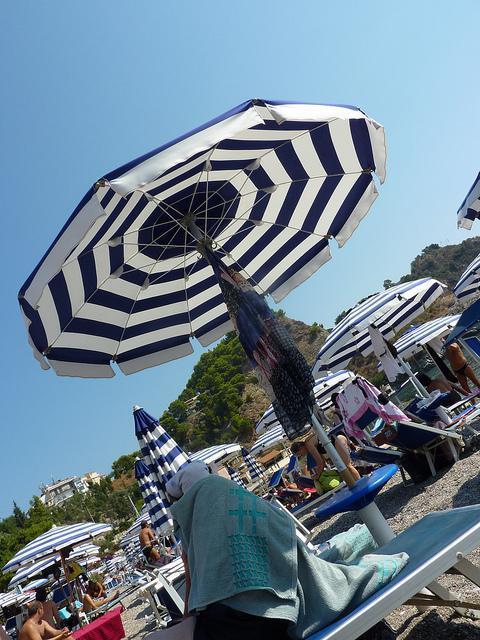How many people are there?
Give a very brief answer. 2. How many umbrellas are there?
Give a very brief answer. 4. 